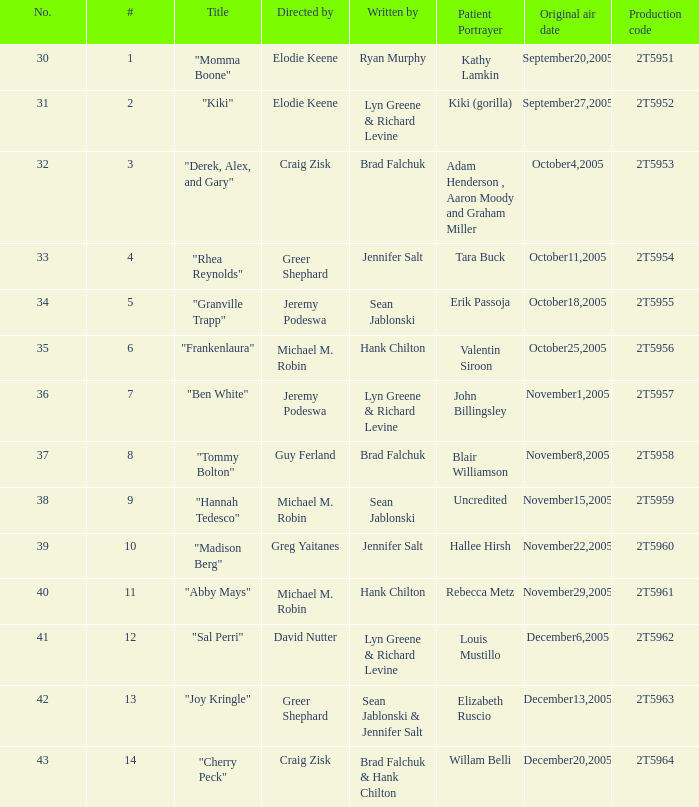Who were the writers for the episode titled "Ben White"? Lyn Greene & Richard Levine. 